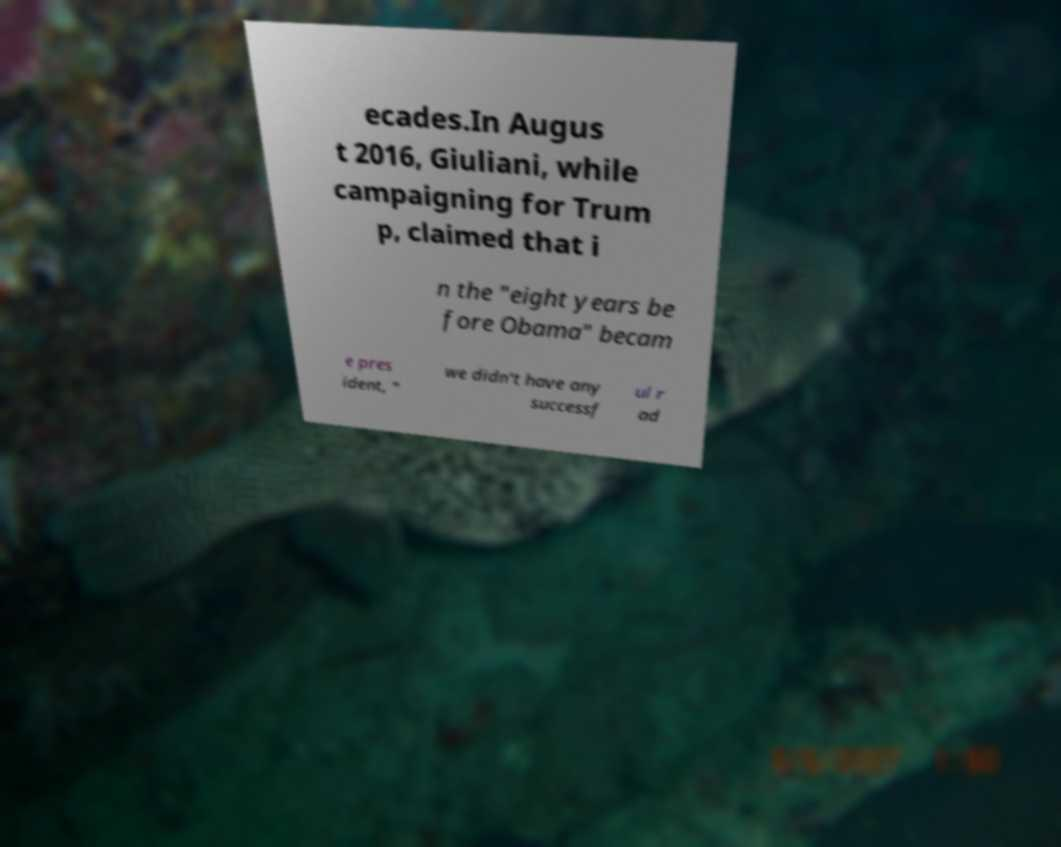Could you extract and type out the text from this image? ecades.In Augus t 2016, Giuliani, while campaigning for Trum p, claimed that i n the "eight years be fore Obama" becam e pres ident, " we didn't have any successf ul r ad 